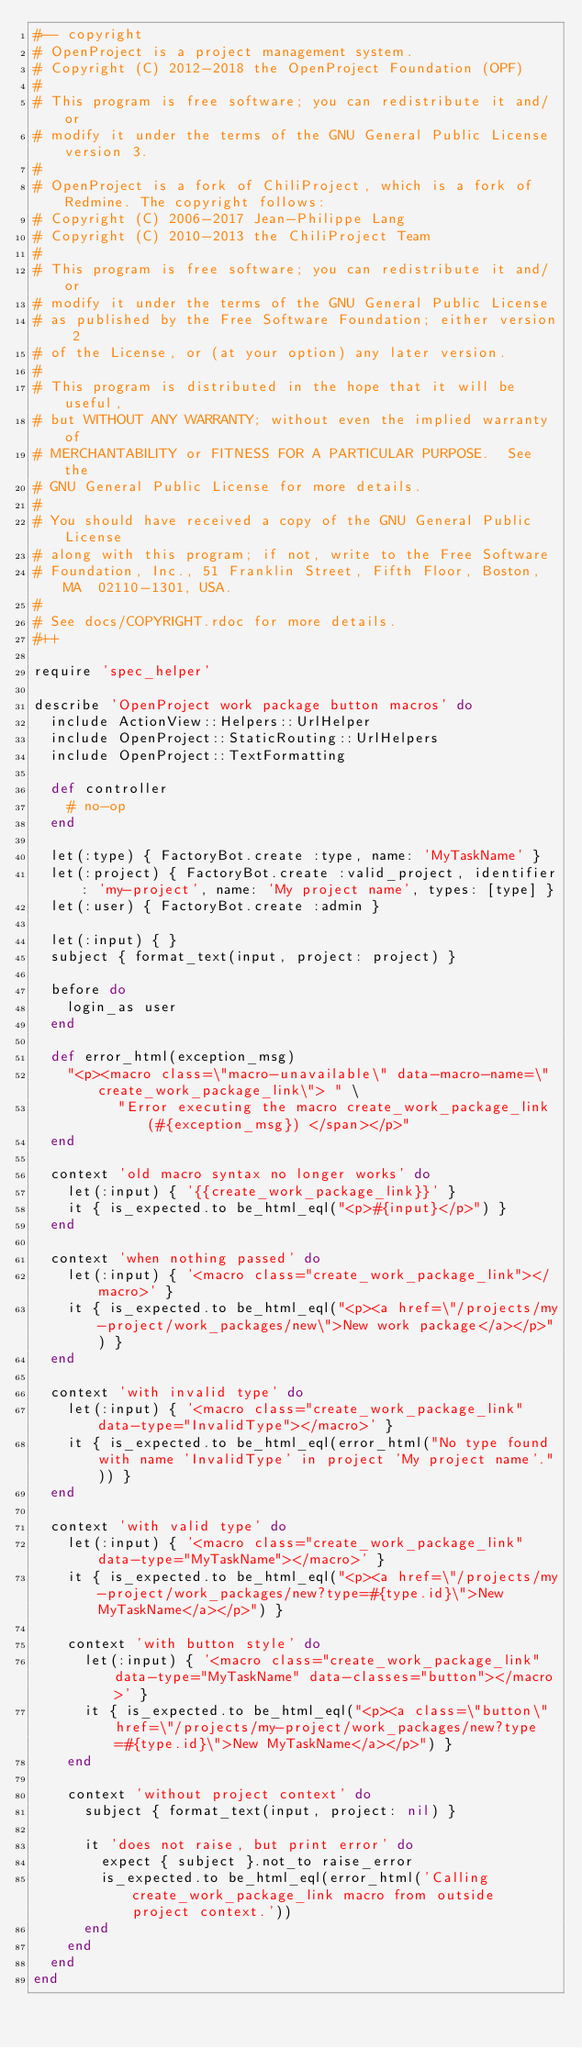<code> <loc_0><loc_0><loc_500><loc_500><_Ruby_>#-- copyright
# OpenProject is a project management system.
# Copyright (C) 2012-2018 the OpenProject Foundation (OPF)
#
# This program is free software; you can redistribute it and/or
# modify it under the terms of the GNU General Public License version 3.
#
# OpenProject is a fork of ChiliProject, which is a fork of Redmine. The copyright follows:
# Copyright (C) 2006-2017 Jean-Philippe Lang
# Copyright (C) 2010-2013 the ChiliProject Team
#
# This program is free software; you can redistribute it and/or
# modify it under the terms of the GNU General Public License
# as published by the Free Software Foundation; either version 2
# of the License, or (at your option) any later version.
#
# This program is distributed in the hope that it will be useful,
# but WITHOUT ANY WARRANTY; without even the implied warranty of
# MERCHANTABILITY or FITNESS FOR A PARTICULAR PURPOSE.  See the
# GNU General Public License for more details.
#
# You should have received a copy of the GNU General Public License
# along with this program; if not, write to the Free Software
# Foundation, Inc., 51 Franklin Street, Fifth Floor, Boston, MA  02110-1301, USA.
#
# See docs/COPYRIGHT.rdoc for more details.
#++

require 'spec_helper'

describe 'OpenProject work package button macros' do
  include ActionView::Helpers::UrlHelper
  include OpenProject::StaticRouting::UrlHelpers
  include OpenProject::TextFormatting

  def controller
    # no-op
  end

  let(:type) { FactoryBot.create :type, name: 'MyTaskName' }
  let(:project) { FactoryBot.create :valid_project, identifier: 'my-project', name: 'My project name', types: [type] }
  let(:user) { FactoryBot.create :admin }

  let(:input) { }
  subject { format_text(input, project: project) }

  before do
    login_as user
  end

  def error_html(exception_msg)
    "<p><macro class=\"macro-unavailable\" data-macro-name=\"create_work_package_link\"> " \
          "Error executing the macro create_work_package_link (#{exception_msg}) </span></p>"
  end

  context 'old macro syntax no longer works' do
    let(:input) { '{{create_work_package_link}}' }
    it { is_expected.to be_html_eql("<p>#{input}</p>") }
  end

  context 'when nothing passed' do
    let(:input) { '<macro class="create_work_package_link"></macro>' }
    it { is_expected.to be_html_eql("<p><a href=\"/projects/my-project/work_packages/new\">New work package</a></p>") }
  end

  context 'with invalid type' do
    let(:input) { '<macro class="create_work_package_link" data-type="InvalidType"></macro>' }
    it { is_expected.to be_html_eql(error_html("No type found with name 'InvalidType' in project 'My project name'.")) }
  end

  context 'with valid type' do
    let(:input) { '<macro class="create_work_package_link" data-type="MyTaskName"></macro>' }
    it { is_expected.to be_html_eql("<p><a href=\"/projects/my-project/work_packages/new?type=#{type.id}\">New MyTaskName</a></p>") }

    context 'with button style' do
      let(:input) { '<macro class="create_work_package_link" data-type="MyTaskName" data-classes="button"></macro>' }
      it { is_expected.to be_html_eql("<p><a class=\"button\" href=\"/projects/my-project/work_packages/new?type=#{type.id}\">New MyTaskName</a></p>") }
    end

    context 'without project context' do
      subject { format_text(input, project: nil) }

      it 'does not raise, but print error' do
        expect { subject }.not_to raise_error
        is_expected.to be_html_eql(error_html('Calling create_work_package_link macro from outside project context.'))
      end
    end
  end
end
</code> 